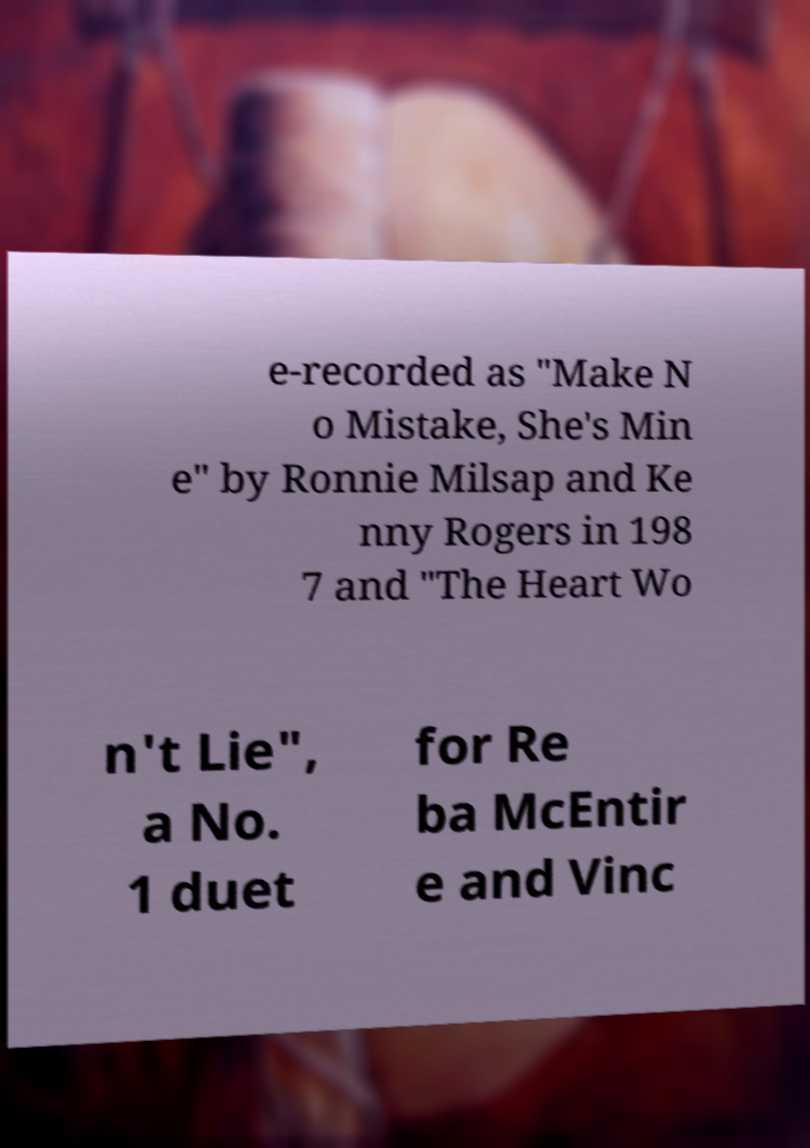Please identify and transcribe the text found in this image. e-recorded as "Make N o Mistake, She's Min e" by Ronnie Milsap and Ke nny Rogers in 198 7 and "The Heart Wo n't Lie", a No. 1 duet for Re ba McEntir e and Vinc 